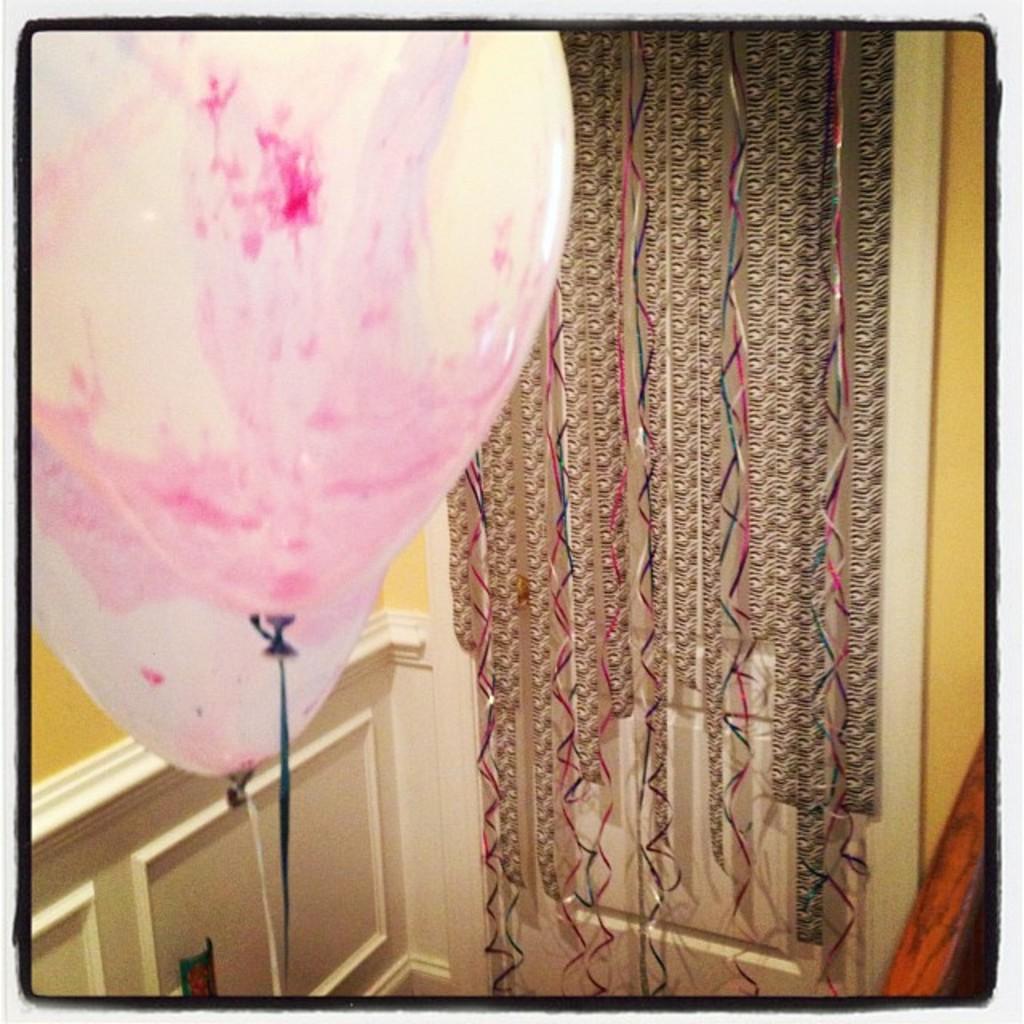In one or two sentences, can you explain what this image depicts? In this picture I can see the balloons. I can see decorative items. 